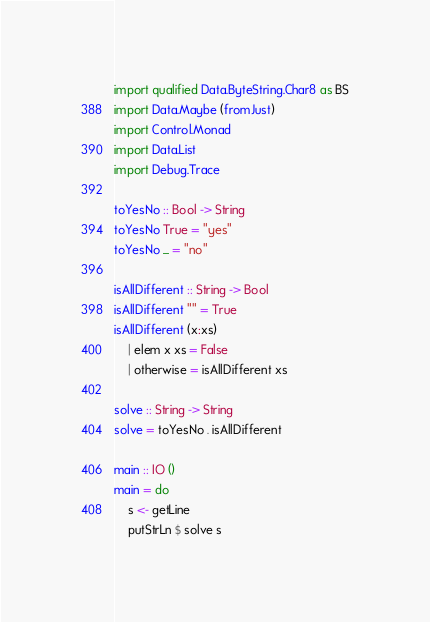Convert code to text. <code><loc_0><loc_0><loc_500><loc_500><_Haskell_>import qualified Data.ByteString.Char8 as BS
import Data.Maybe (fromJust)
import Control.Monad
import Data.List
import Debug.Trace

toYesNo :: Bool -> String
toYesNo True = "yes"
toYesNo _ = "no"

isAllDifferent :: String -> Bool
isAllDifferent "" = True
isAllDifferent (x:xs)
    | elem x xs = False
    | otherwise = isAllDifferent xs

solve :: String -> String
solve = toYesNo . isAllDifferent

main :: IO ()
main = do
    s <- getLine
    putStrLn $ solve s
</code> 